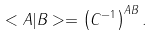<formula> <loc_0><loc_0><loc_500><loc_500>< A | B > = \left ( C ^ { - 1 } \right ) ^ { A B } .</formula> 